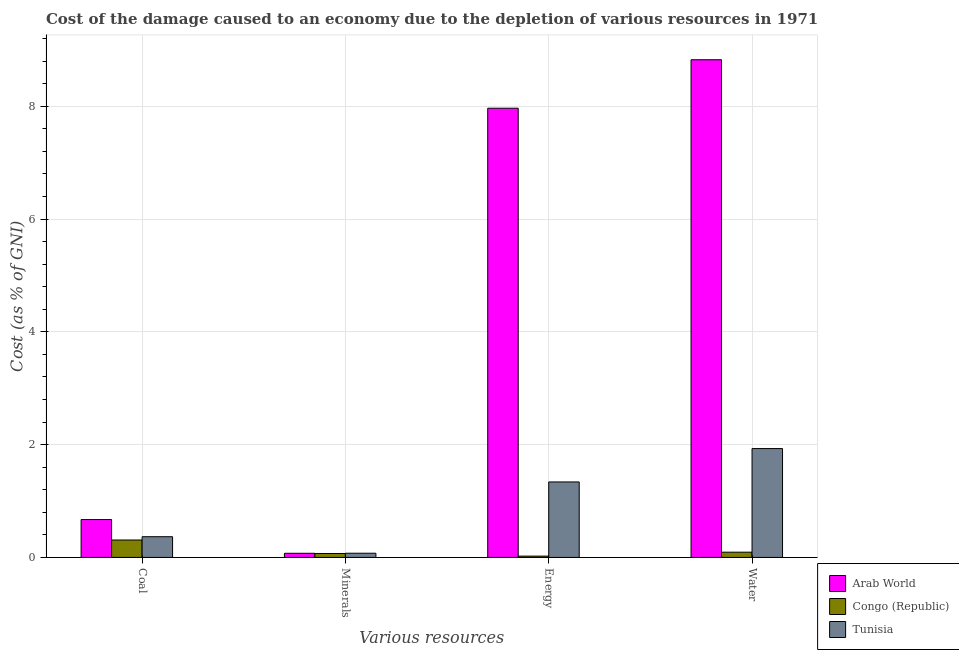How many different coloured bars are there?
Your response must be concise. 3. How many groups of bars are there?
Ensure brevity in your answer.  4. Are the number of bars per tick equal to the number of legend labels?
Offer a terse response. Yes. Are the number of bars on each tick of the X-axis equal?
Your answer should be compact. Yes. How many bars are there on the 1st tick from the left?
Ensure brevity in your answer.  3. How many bars are there on the 3rd tick from the right?
Give a very brief answer. 3. What is the label of the 3rd group of bars from the left?
Provide a short and direct response. Energy. What is the cost of damage due to depletion of coal in Tunisia?
Provide a succinct answer. 0.37. Across all countries, what is the maximum cost of damage due to depletion of coal?
Ensure brevity in your answer.  0.67. Across all countries, what is the minimum cost of damage due to depletion of coal?
Provide a short and direct response. 0.31. In which country was the cost of damage due to depletion of coal maximum?
Your response must be concise. Arab World. In which country was the cost of damage due to depletion of water minimum?
Keep it short and to the point. Congo (Republic). What is the total cost of damage due to depletion of minerals in the graph?
Your response must be concise. 0.22. What is the difference between the cost of damage due to depletion of coal in Congo (Republic) and that in Arab World?
Offer a very short reply. -0.36. What is the difference between the cost of damage due to depletion of energy in Congo (Republic) and the cost of damage due to depletion of water in Arab World?
Provide a succinct answer. -8.8. What is the average cost of damage due to depletion of coal per country?
Offer a terse response. 0.45. What is the difference between the cost of damage due to depletion of energy and cost of damage due to depletion of water in Tunisia?
Your response must be concise. -0.59. What is the ratio of the cost of damage due to depletion of coal in Congo (Republic) to that in Tunisia?
Offer a terse response. 0.84. Is the difference between the cost of damage due to depletion of coal in Arab World and Tunisia greater than the difference between the cost of damage due to depletion of energy in Arab World and Tunisia?
Provide a succinct answer. No. What is the difference between the highest and the second highest cost of damage due to depletion of energy?
Give a very brief answer. 6.63. What is the difference between the highest and the lowest cost of damage due to depletion of minerals?
Keep it short and to the point. 0. Is the sum of the cost of damage due to depletion of minerals in Arab World and Congo (Republic) greater than the maximum cost of damage due to depletion of coal across all countries?
Your answer should be compact. No. What does the 1st bar from the left in Water represents?
Your response must be concise. Arab World. What does the 1st bar from the right in Minerals represents?
Your answer should be compact. Tunisia. How many bars are there?
Make the answer very short. 12. Are all the bars in the graph horizontal?
Keep it short and to the point. No. What is the difference between two consecutive major ticks on the Y-axis?
Your answer should be very brief. 2. Does the graph contain any zero values?
Your answer should be compact. No. Does the graph contain grids?
Your answer should be compact. Yes. Where does the legend appear in the graph?
Your answer should be very brief. Bottom right. How are the legend labels stacked?
Your answer should be compact. Vertical. What is the title of the graph?
Your response must be concise. Cost of the damage caused to an economy due to the depletion of various resources in 1971 . Does "Ukraine" appear as one of the legend labels in the graph?
Offer a terse response. No. What is the label or title of the X-axis?
Your answer should be very brief. Various resources. What is the label or title of the Y-axis?
Provide a short and direct response. Cost (as % of GNI). What is the Cost (as % of GNI) in Arab World in Coal?
Ensure brevity in your answer.  0.67. What is the Cost (as % of GNI) of Congo (Republic) in Coal?
Make the answer very short. 0.31. What is the Cost (as % of GNI) in Tunisia in Coal?
Ensure brevity in your answer.  0.37. What is the Cost (as % of GNI) in Arab World in Minerals?
Provide a succinct answer. 0.07. What is the Cost (as % of GNI) in Congo (Republic) in Minerals?
Ensure brevity in your answer.  0.07. What is the Cost (as % of GNI) of Tunisia in Minerals?
Keep it short and to the point. 0.07. What is the Cost (as % of GNI) in Arab World in Energy?
Give a very brief answer. 7.96. What is the Cost (as % of GNI) of Congo (Republic) in Energy?
Give a very brief answer. 0.02. What is the Cost (as % of GNI) of Tunisia in Energy?
Offer a very short reply. 1.34. What is the Cost (as % of GNI) of Arab World in Water?
Give a very brief answer. 8.82. What is the Cost (as % of GNI) in Congo (Republic) in Water?
Your response must be concise. 0.09. What is the Cost (as % of GNI) in Tunisia in Water?
Your response must be concise. 1.93. Across all Various resources, what is the maximum Cost (as % of GNI) of Arab World?
Ensure brevity in your answer.  8.82. Across all Various resources, what is the maximum Cost (as % of GNI) in Congo (Republic)?
Your answer should be very brief. 0.31. Across all Various resources, what is the maximum Cost (as % of GNI) of Tunisia?
Your answer should be very brief. 1.93. Across all Various resources, what is the minimum Cost (as % of GNI) of Arab World?
Make the answer very short. 0.07. Across all Various resources, what is the minimum Cost (as % of GNI) in Congo (Republic)?
Give a very brief answer. 0.02. Across all Various resources, what is the minimum Cost (as % of GNI) of Tunisia?
Your answer should be very brief. 0.07. What is the total Cost (as % of GNI) of Arab World in the graph?
Provide a succinct answer. 17.53. What is the total Cost (as % of GNI) in Congo (Republic) in the graph?
Keep it short and to the point. 0.49. What is the total Cost (as % of GNI) of Tunisia in the graph?
Offer a terse response. 3.71. What is the difference between the Cost (as % of GNI) of Arab World in Coal and that in Minerals?
Give a very brief answer. 0.6. What is the difference between the Cost (as % of GNI) in Congo (Republic) in Coal and that in Minerals?
Give a very brief answer. 0.24. What is the difference between the Cost (as % of GNI) of Tunisia in Coal and that in Minerals?
Offer a very short reply. 0.29. What is the difference between the Cost (as % of GNI) of Arab World in Coal and that in Energy?
Your response must be concise. -7.29. What is the difference between the Cost (as % of GNI) in Congo (Republic) in Coal and that in Energy?
Your answer should be very brief. 0.29. What is the difference between the Cost (as % of GNI) of Tunisia in Coal and that in Energy?
Your response must be concise. -0.97. What is the difference between the Cost (as % of GNI) in Arab World in Coal and that in Water?
Make the answer very short. -8.15. What is the difference between the Cost (as % of GNI) in Congo (Republic) in Coal and that in Water?
Make the answer very short. 0.22. What is the difference between the Cost (as % of GNI) in Tunisia in Coal and that in Water?
Provide a short and direct response. -1.56. What is the difference between the Cost (as % of GNI) in Arab World in Minerals and that in Energy?
Give a very brief answer. -7.89. What is the difference between the Cost (as % of GNI) of Congo (Republic) in Minerals and that in Energy?
Ensure brevity in your answer.  0.05. What is the difference between the Cost (as % of GNI) of Tunisia in Minerals and that in Energy?
Your answer should be compact. -1.26. What is the difference between the Cost (as % of GNI) in Arab World in Minerals and that in Water?
Offer a terse response. -8.75. What is the difference between the Cost (as % of GNI) in Congo (Republic) in Minerals and that in Water?
Your response must be concise. -0.02. What is the difference between the Cost (as % of GNI) of Tunisia in Minerals and that in Water?
Offer a very short reply. -1.86. What is the difference between the Cost (as % of GNI) of Arab World in Energy and that in Water?
Your answer should be very brief. -0.86. What is the difference between the Cost (as % of GNI) of Congo (Republic) in Energy and that in Water?
Offer a terse response. -0.07. What is the difference between the Cost (as % of GNI) in Tunisia in Energy and that in Water?
Offer a very short reply. -0.59. What is the difference between the Cost (as % of GNI) of Arab World in Coal and the Cost (as % of GNI) of Congo (Republic) in Minerals?
Your answer should be very brief. 0.6. What is the difference between the Cost (as % of GNI) in Arab World in Coal and the Cost (as % of GNI) in Tunisia in Minerals?
Your answer should be compact. 0.6. What is the difference between the Cost (as % of GNI) of Congo (Republic) in Coal and the Cost (as % of GNI) of Tunisia in Minerals?
Your answer should be compact. 0.23. What is the difference between the Cost (as % of GNI) in Arab World in Coal and the Cost (as % of GNI) in Congo (Republic) in Energy?
Your answer should be very brief. 0.65. What is the difference between the Cost (as % of GNI) of Congo (Republic) in Coal and the Cost (as % of GNI) of Tunisia in Energy?
Offer a very short reply. -1.03. What is the difference between the Cost (as % of GNI) of Arab World in Coal and the Cost (as % of GNI) of Congo (Republic) in Water?
Provide a succinct answer. 0.58. What is the difference between the Cost (as % of GNI) of Arab World in Coal and the Cost (as % of GNI) of Tunisia in Water?
Offer a very short reply. -1.26. What is the difference between the Cost (as % of GNI) in Congo (Republic) in Coal and the Cost (as % of GNI) in Tunisia in Water?
Make the answer very short. -1.62. What is the difference between the Cost (as % of GNI) of Arab World in Minerals and the Cost (as % of GNI) of Congo (Republic) in Energy?
Offer a terse response. 0.05. What is the difference between the Cost (as % of GNI) in Arab World in Minerals and the Cost (as % of GNI) in Tunisia in Energy?
Your answer should be compact. -1.27. What is the difference between the Cost (as % of GNI) in Congo (Republic) in Minerals and the Cost (as % of GNI) in Tunisia in Energy?
Offer a terse response. -1.27. What is the difference between the Cost (as % of GNI) in Arab World in Minerals and the Cost (as % of GNI) in Congo (Republic) in Water?
Your answer should be very brief. -0.02. What is the difference between the Cost (as % of GNI) of Arab World in Minerals and the Cost (as % of GNI) of Tunisia in Water?
Your response must be concise. -1.86. What is the difference between the Cost (as % of GNI) of Congo (Republic) in Minerals and the Cost (as % of GNI) of Tunisia in Water?
Your answer should be very brief. -1.86. What is the difference between the Cost (as % of GNI) in Arab World in Energy and the Cost (as % of GNI) in Congo (Republic) in Water?
Provide a succinct answer. 7.87. What is the difference between the Cost (as % of GNI) in Arab World in Energy and the Cost (as % of GNI) in Tunisia in Water?
Your answer should be very brief. 6.03. What is the difference between the Cost (as % of GNI) in Congo (Republic) in Energy and the Cost (as % of GNI) in Tunisia in Water?
Keep it short and to the point. -1.91. What is the average Cost (as % of GNI) of Arab World per Various resources?
Your response must be concise. 4.38. What is the average Cost (as % of GNI) in Congo (Republic) per Various resources?
Your answer should be very brief. 0.12. What is the average Cost (as % of GNI) in Tunisia per Various resources?
Provide a short and direct response. 0.93. What is the difference between the Cost (as % of GNI) of Arab World and Cost (as % of GNI) of Congo (Republic) in Coal?
Ensure brevity in your answer.  0.36. What is the difference between the Cost (as % of GNI) in Arab World and Cost (as % of GNI) in Tunisia in Coal?
Give a very brief answer. 0.3. What is the difference between the Cost (as % of GNI) in Congo (Republic) and Cost (as % of GNI) in Tunisia in Coal?
Provide a short and direct response. -0.06. What is the difference between the Cost (as % of GNI) of Arab World and Cost (as % of GNI) of Congo (Republic) in Minerals?
Offer a very short reply. 0. What is the difference between the Cost (as % of GNI) in Arab World and Cost (as % of GNI) in Tunisia in Minerals?
Provide a succinct answer. -0. What is the difference between the Cost (as % of GNI) in Congo (Republic) and Cost (as % of GNI) in Tunisia in Minerals?
Your answer should be compact. -0. What is the difference between the Cost (as % of GNI) in Arab World and Cost (as % of GNI) in Congo (Republic) in Energy?
Your answer should be very brief. 7.94. What is the difference between the Cost (as % of GNI) of Arab World and Cost (as % of GNI) of Tunisia in Energy?
Give a very brief answer. 6.63. What is the difference between the Cost (as % of GNI) of Congo (Republic) and Cost (as % of GNI) of Tunisia in Energy?
Give a very brief answer. -1.31. What is the difference between the Cost (as % of GNI) of Arab World and Cost (as % of GNI) of Congo (Republic) in Water?
Offer a terse response. 8.73. What is the difference between the Cost (as % of GNI) in Arab World and Cost (as % of GNI) in Tunisia in Water?
Offer a very short reply. 6.89. What is the difference between the Cost (as % of GNI) of Congo (Republic) and Cost (as % of GNI) of Tunisia in Water?
Your response must be concise. -1.84. What is the ratio of the Cost (as % of GNI) in Arab World in Coal to that in Minerals?
Your response must be concise. 9.17. What is the ratio of the Cost (as % of GNI) in Congo (Republic) in Coal to that in Minerals?
Give a very brief answer. 4.43. What is the ratio of the Cost (as % of GNI) in Tunisia in Coal to that in Minerals?
Keep it short and to the point. 4.94. What is the ratio of the Cost (as % of GNI) in Arab World in Coal to that in Energy?
Offer a terse response. 0.08. What is the ratio of the Cost (as % of GNI) of Congo (Republic) in Coal to that in Energy?
Provide a succinct answer. 13.25. What is the ratio of the Cost (as % of GNI) in Tunisia in Coal to that in Energy?
Keep it short and to the point. 0.27. What is the ratio of the Cost (as % of GNI) in Arab World in Coal to that in Water?
Your answer should be compact. 0.08. What is the ratio of the Cost (as % of GNI) of Congo (Republic) in Coal to that in Water?
Provide a short and direct response. 3.32. What is the ratio of the Cost (as % of GNI) of Tunisia in Coal to that in Water?
Your response must be concise. 0.19. What is the ratio of the Cost (as % of GNI) in Arab World in Minerals to that in Energy?
Give a very brief answer. 0.01. What is the ratio of the Cost (as % of GNI) in Congo (Republic) in Minerals to that in Energy?
Ensure brevity in your answer.  2.99. What is the ratio of the Cost (as % of GNI) of Tunisia in Minerals to that in Energy?
Your response must be concise. 0.06. What is the ratio of the Cost (as % of GNI) in Arab World in Minerals to that in Water?
Offer a terse response. 0.01. What is the ratio of the Cost (as % of GNI) in Congo (Republic) in Minerals to that in Water?
Your answer should be very brief. 0.75. What is the ratio of the Cost (as % of GNI) in Tunisia in Minerals to that in Water?
Offer a terse response. 0.04. What is the ratio of the Cost (as % of GNI) of Arab World in Energy to that in Water?
Make the answer very short. 0.9. What is the ratio of the Cost (as % of GNI) of Congo (Republic) in Energy to that in Water?
Your response must be concise. 0.25. What is the ratio of the Cost (as % of GNI) of Tunisia in Energy to that in Water?
Your answer should be very brief. 0.69. What is the difference between the highest and the second highest Cost (as % of GNI) in Arab World?
Your response must be concise. 0.86. What is the difference between the highest and the second highest Cost (as % of GNI) of Congo (Republic)?
Offer a terse response. 0.22. What is the difference between the highest and the second highest Cost (as % of GNI) in Tunisia?
Your answer should be very brief. 0.59. What is the difference between the highest and the lowest Cost (as % of GNI) of Arab World?
Your answer should be compact. 8.75. What is the difference between the highest and the lowest Cost (as % of GNI) in Congo (Republic)?
Ensure brevity in your answer.  0.29. What is the difference between the highest and the lowest Cost (as % of GNI) in Tunisia?
Your response must be concise. 1.86. 